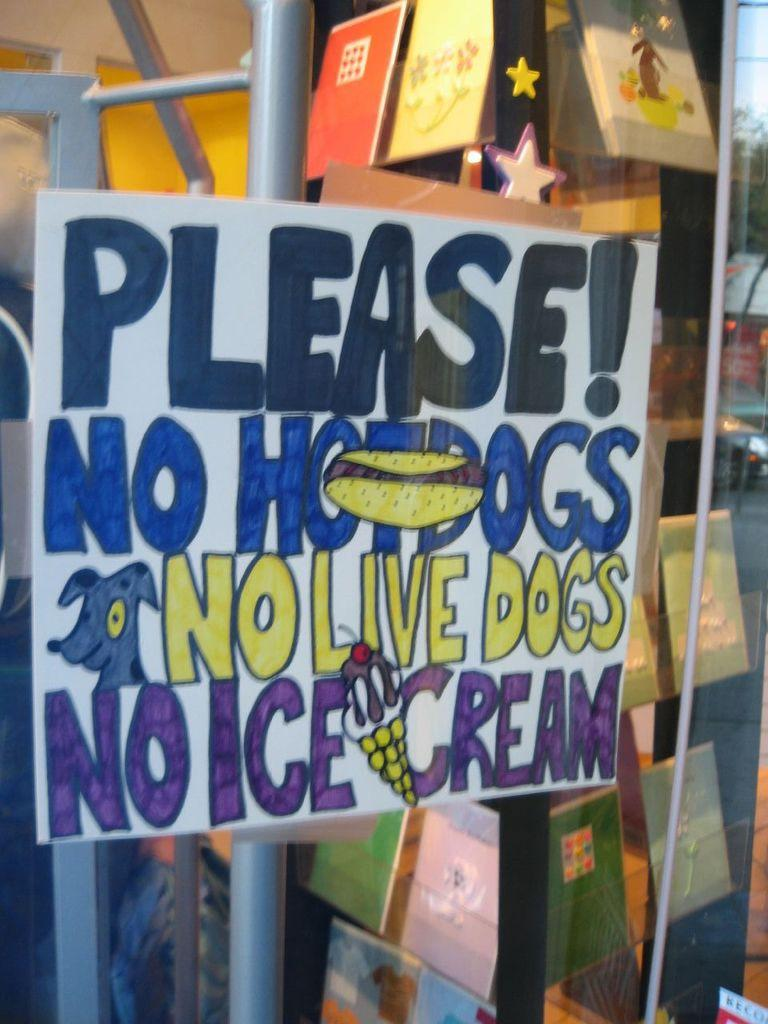<image>
Give a short and clear explanation of the subsequent image. A sign which requests no hot dogs, dogs or ice cream. 